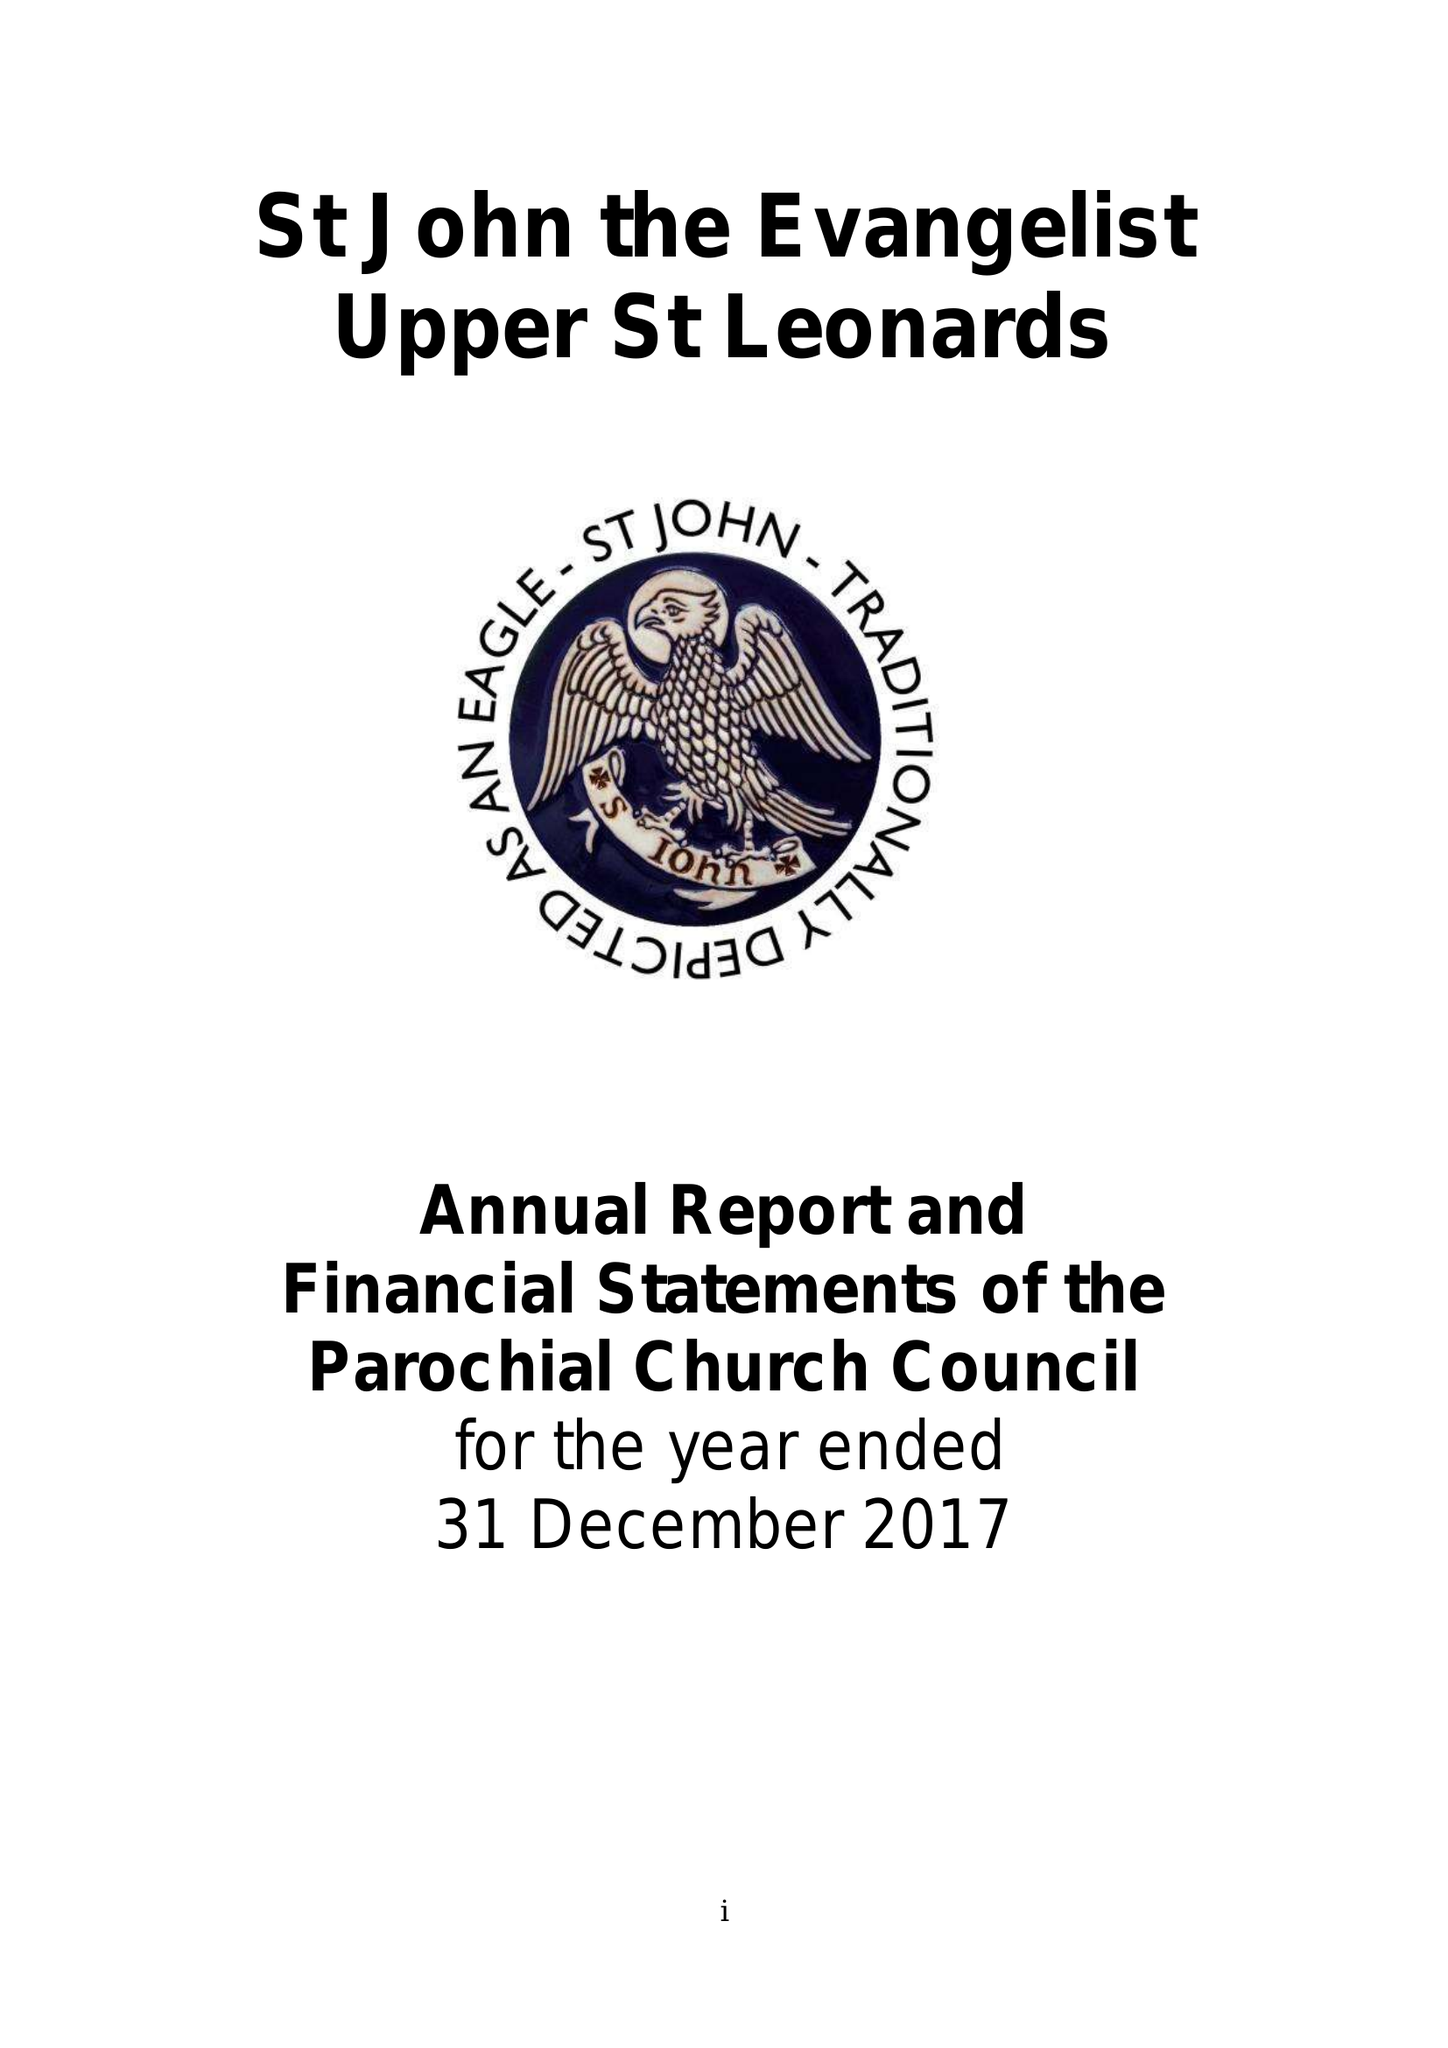What is the value for the charity_name?
Answer the question using a single word or phrase. The Parochial Church Council Of The Ecclesiastical Parish Of St John The Evangelist Upper St Leonards On Sea 